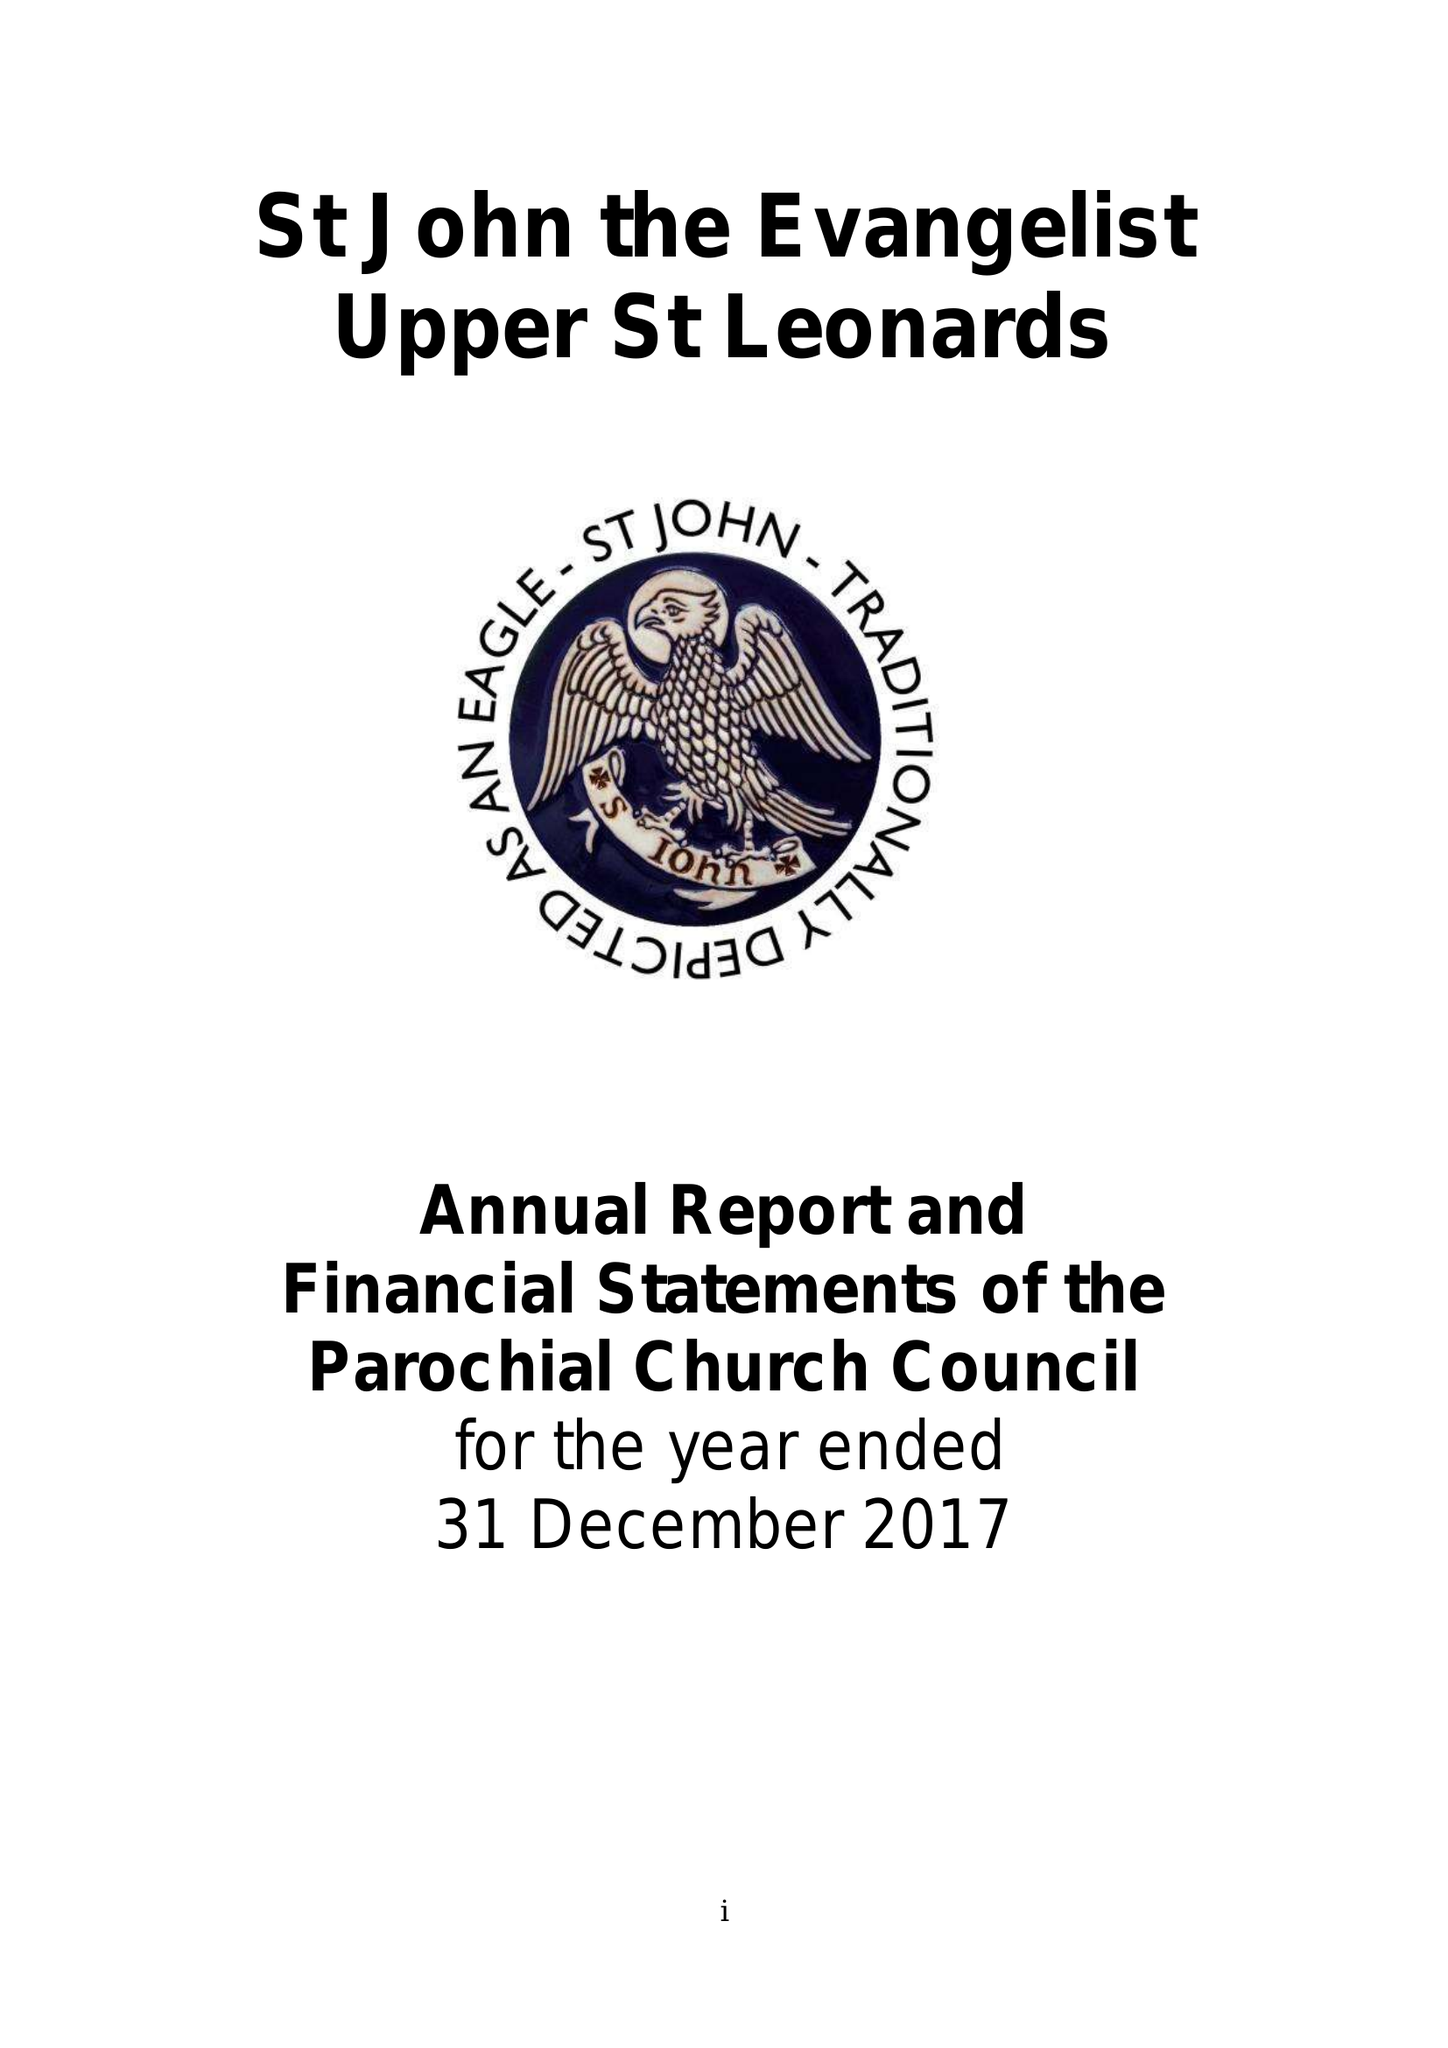What is the value for the charity_name?
Answer the question using a single word or phrase. The Parochial Church Council Of The Ecclesiastical Parish Of St John The Evangelist Upper St Leonards On Sea 